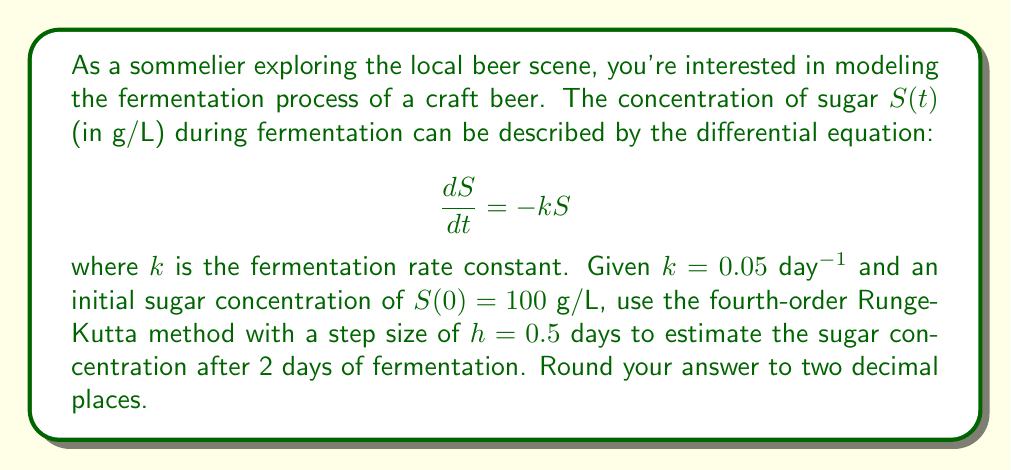Teach me how to tackle this problem. To solve this problem, we'll use the fourth-order Runge-Kutta (RK4) method to numerically approximate the solution to the differential equation. The RK4 method is given by:

$$y_{n+1} = y_n + \frac{1}{6}(k_1 + 2k_2 + 2k_3 + k_4)$$

where:
$$\begin{align*}
k_1 &= hf(t_n, y_n) \\
k_2 &= hf(t_n + \frac{h}{2}, y_n + \frac{k_1}{2}) \\
k_3 &= hf(t_n + \frac{h}{2}, y_n + \frac{k_2}{2}) \\
k_4 &= hf(t_n + h, y_n + k_3)
\end{align*}$$

In our case, $f(t, S) = -kS = -0.05S$.

We need to perform 4 steps to reach t = 2 days (since h = 0.5 days).

Step 1 (t = 0 to t = 0.5):
$$\begin{align*}
k_1 &= 0.5 \cdot (-0.05 \cdot 100) = -2.5 \\
k_2 &= 0.5 \cdot (-0.05 \cdot (100 - 1.25)) = -2.46875 \\
k_3 &= 0.5 \cdot (-0.05 \cdot (100 - 1.234375)) = -2.46914 \\
k_4 &= 0.5 \cdot (-0.05 \cdot (100 - 2.46914)) = -2.43827 \\
S(0.5) &= 100 + \frac{1}{6}(-2.5 - 2 \cdot 2.46875 - 2 \cdot 2.46914 - 2.43827) = 97.5311
\end{align*}$$

Step 2 (t = 0.5 to t = 1):
$$\begin{align*}
k_1 &= 0.5 \cdot (-0.05 \cdot 97.5311) = -2.43828 \\
k_2 &= 0.5 \cdot (-0.05 \cdot (97.5311 - 1.21914)) = -2.40728 \\
k_3 &= 0.5 \cdot (-0.05 \cdot (97.5311 - 1.20364)) = -2.40767 \\
k_4 &= 0.5 \cdot (-0.05 \cdot (97.5311 - 2.40767)) = -2.37763 \\
S(1) &= 97.5311 + \frac{1}{6}(-2.43828 - 2 \cdot 2.40728 - 2 \cdot 2.40767 - 2.37763) = 95.1214
\end{align*}$$

Step 3 (t = 1 to t = 1.5):
$$\begin{align*}
k_1 &= 0.5 \cdot (-0.05 \cdot 95.1214) = -2.37804 \\
k_2 &= 0.5 \cdot (-0.05 \cdot (95.1214 - 1.18902)) = -2.34828 \\
k_3 &= 0.5 \cdot (-0.05 \cdot (95.1214 - 1.17414)) = -2.34865 \\
k_4 &= 0.5 \cdot (-0.05 \cdot (95.1214 - 2.34865)) = -2.31937 \\
S(1.5) &= 95.1214 + \frac{1}{6}(-2.37804 - 2 \cdot 2.34828 - 2 \cdot 2.34865 - 2.31937) = 92.7694
\end{align*}$$

Step 4 (t = 1.5 to t = 2):
$$\begin{align*}
k_1 &= 0.5 \cdot (-0.05 \cdot 92.7694) = -2.31924 \\
k_2 &= 0.5 \cdot (-0.05 \cdot (92.7694 - 1.15962)) = -2.29068 \\
k_3 &= 0.5 \cdot (-0.05 \cdot (92.7694 - 1.14534)) = -2.29104 \\
k_4 &= 0.5 \cdot (-0.05 \cdot (92.7694 - 2.29104)) = -2.26296 \\
S(2) &= 92.7694 + \frac{1}{6}(-2.31924 - 2 \cdot 2.29068 - 2 \cdot 2.29104 - 2.26296) = 90.4735
\end{align*}$$
Answer: The estimated sugar concentration after 2 days of fermentation is $90.47$ g/L. 